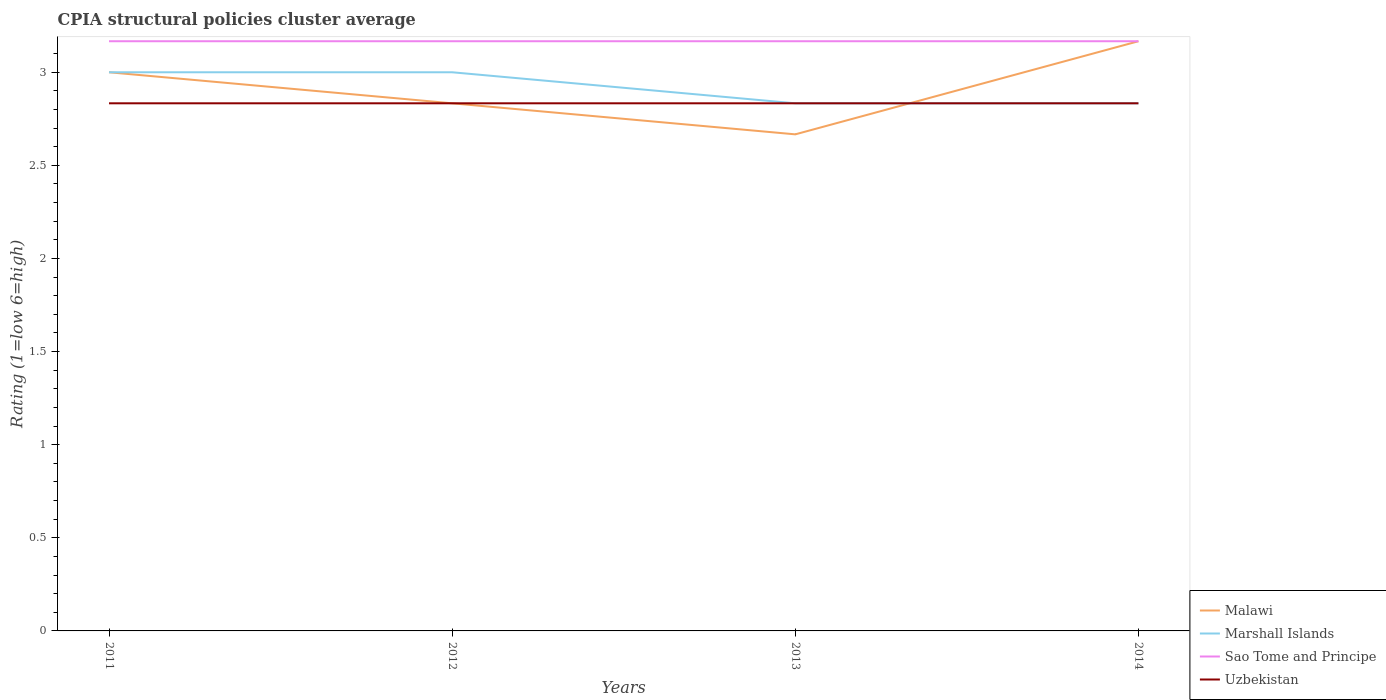Does the line corresponding to Malawi intersect with the line corresponding to Sao Tome and Principe?
Offer a very short reply. Yes. Across all years, what is the maximum CPIA rating in Marshall Islands?
Your response must be concise. 2.83. In which year was the CPIA rating in Marshall Islands maximum?
Ensure brevity in your answer.  2014. What is the total CPIA rating in Marshall Islands in the graph?
Keep it short and to the point. 0.17. What is the difference between the highest and the second highest CPIA rating in Marshall Islands?
Offer a very short reply. 0.17. How many years are there in the graph?
Make the answer very short. 4. Where does the legend appear in the graph?
Your answer should be very brief. Bottom right. How many legend labels are there?
Provide a succinct answer. 4. What is the title of the graph?
Provide a short and direct response. CPIA structural policies cluster average. Does "High income" appear as one of the legend labels in the graph?
Offer a very short reply. No. What is the Rating (1=low 6=high) of Malawi in 2011?
Provide a succinct answer. 3. What is the Rating (1=low 6=high) of Marshall Islands in 2011?
Provide a short and direct response. 3. What is the Rating (1=low 6=high) in Sao Tome and Principe in 2011?
Keep it short and to the point. 3.17. What is the Rating (1=low 6=high) of Uzbekistan in 2011?
Offer a very short reply. 2.83. What is the Rating (1=low 6=high) of Malawi in 2012?
Your answer should be compact. 2.83. What is the Rating (1=low 6=high) of Marshall Islands in 2012?
Offer a very short reply. 3. What is the Rating (1=low 6=high) in Sao Tome and Principe in 2012?
Your answer should be very brief. 3.17. What is the Rating (1=low 6=high) in Uzbekistan in 2012?
Offer a very short reply. 2.83. What is the Rating (1=low 6=high) of Malawi in 2013?
Your answer should be very brief. 2.67. What is the Rating (1=low 6=high) of Marshall Islands in 2013?
Your response must be concise. 2.83. What is the Rating (1=low 6=high) in Sao Tome and Principe in 2013?
Provide a short and direct response. 3.17. What is the Rating (1=low 6=high) in Uzbekistan in 2013?
Provide a succinct answer. 2.83. What is the Rating (1=low 6=high) of Malawi in 2014?
Offer a very short reply. 3.17. What is the Rating (1=low 6=high) of Marshall Islands in 2014?
Your response must be concise. 2.83. What is the Rating (1=low 6=high) of Sao Tome and Principe in 2014?
Provide a succinct answer. 3.17. What is the Rating (1=low 6=high) of Uzbekistan in 2014?
Your response must be concise. 2.83. Across all years, what is the maximum Rating (1=low 6=high) in Malawi?
Your response must be concise. 3.17. Across all years, what is the maximum Rating (1=low 6=high) of Sao Tome and Principe?
Provide a succinct answer. 3.17. Across all years, what is the maximum Rating (1=low 6=high) in Uzbekistan?
Keep it short and to the point. 2.83. Across all years, what is the minimum Rating (1=low 6=high) of Malawi?
Your answer should be compact. 2.67. Across all years, what is the minimum Rating (1=low 6=high) in Marshall Islands?
Offer a very short reply. 2.83. Across all years, what is the minimum Rating (1=low 6=high) of Sao Tome and Principe?
Your answer should be very brief. 3.17. Across all years, what is the minimum Rating (1=low 6=high) of Uzbekistan?
Give a very brief answer. 2.83. What is the total Rating (1=low 6=high) in Malawi in the graph?
Ensure brevity in your answer.  11.67. What is the total Rating (1=low 6=high) in Marshall Islands in the graph?
Make the answer very short. 11.67. What is the total Rating (1=low 6=high) of Sao Tome and Principe in the graph?
Provide a succinct answer. 12.67. What is the total Rating (1=low 6=high) of Uzbekistan in the graph?
Provide a short and direct response. 11.33. What is the difference between the Rating (1=low 6=high) of Malawi in 2011 and that in 2012?
Your answer should be compact. 0.17. What is the difference between the Rating (1=low 6=high) of Uzbekistan in 2011 and that in 2012?
Provide a succinct answer. 0. What is the difference between the Rating (1=low 6=high) in Malawi in 2011 and that in 2013?
Provide a succinct answer. 0.33. What is the difference between the Rating (1=low 6=high) in Marshall Islands in 2011 and that in 2013?
Offer a terse response. 0.17. What is the difference between the Rating (1=low 6=high) of Malawi in 2011 and that in 2014?
Your answer should be very brief. -0.17. What is the difference between the Rating (1=low 6=high) in Uzbekistan in 2012 and that in 2013?
Keep it short and to the point. 0. What is the difference between the Rating (1=low 6=high) of Malawi in 2012 and that in 2014?
Make the answer very short. -0.33. What is the difference between the Rating (1=low 6=high) in Marshall Islands in 2012 and that in 2014?
Make the answer very short. 0.17. What is the difference between the Rating (1=low 6=high) in Uzbekistan in 2012 and that in 2014?
Provide a succinct answer. 0. What is the difference between the Rating (1=low 6=high) in Marshall Islands in 2013 and that in 2014?
Ensure brevity in your answer.  0. What is the difference between the Rating (1=low 6=high) in Sao Tome and Principe in 2013 and that in 2014?
Ensure brevity in your answer.  -0. What is the difference between the Rating (1=low 6=high) in Uzbekistan in 2013 and that in 2014?
Keep it short and to the point. 0. What is the difference between the Rating (1=low 6=high) of Malawi in 2011 and the Rating (1=low 6=high) of Uzbekistan in 2012?
Ensure brevity in your answer.  0.17. What is the difference between the Rating (1=low 6=high) in Marshall Islands in 2011 and the Rating (1=low 6=high) in Sao Tome and Principe in 2012?
Keep it short and to the point. -0.17. What is the difference between the Rating (1=low 6=high) of Marshall Islands in 2011 and the Rating (1=low 6=high) of Uzbekistan in 2012?
Provide a succinct answer. 0.17. What is the difference between the Rating (1=low 6=high) in Malawi in 2011 and the Rating (1=low 6=high) in Sao Tome and Principe in 2013?
Offer a terse response. -0.17. What is the difference between the Rating (1=low 6=high) in Malawi in 2011 and the Rating (1=low 6=high) in Uzbekistan in 2013?
Give a very brief answer. 0.17. What is the difference between the Rating (1=low 6=high) in Marshall Islands in 2011 and the Rating (1=low 6=high) in Uzbekistan in 2013?
Give a very brief answer. 0.17. What is the difference between the Rating (1=low 6=high) of Malawi in 2011 and the Rating (1=low 6=high) of Marshall Islands in 2014?
Your answer should be very brief. 0.17. What is the difference between the Rating (1=low 6=high) in Malawi in 2011 and the Rating (1=low 6=high) in Sao Tome and Principe in 2014?
Your response must be concise. -0.17. What is the difference between the Rating (1=low 6=high) of Marshall Islands in 2011 and the Rating (1=low 6=high) of Sao Tome and Principe in 2014?
Your response must be concise. -0.17. What is the difference between the Rating (1=low 6=high) in Sao Tome and Principe in 2011 and the Rating (1=low 6=high) in Uzbekistan in 2014?
Provide a short and direct response. 0.33. What is the difference between the Rating (1=low 6=high) in Malawi in 2012 and the Rating (1=low 6=high) in Sao Tome and Principe in 2013?
Your answer should be very brief. -0.33. What is the difference between the Rating (1=low 6=high) in Malawi in 2012 and the Rating (1=low 6=high) in Uzbekistan in 2013?
Offer a very short reply. 0. What is the difference between the Rating (1=low 6=high) in Marshall Islands in 2012 and the Rating (1=low 6=high) in Sao Tome and Principe in 2013?
Provide a short and direct response. -0.17. What is the difference between the Rating (1=low 6=high) in Marshall Islands in 2012 and the Rating (1=low 6=high) in Sao Tome and Principe in 2014?
Your answer should be compact. -0.17. What is the difference between the Rating (1=low 6=high) of Marshall Islands in 2012 and the Rating (1=low 6=high) of Uzbekistan in 2014?
Make the answer very short. 0.17. What is the difference between the Rating (1=low 6=high) of Malawi in 2013 and the Rating (1=low 6=high) of Uzbekistan in 2014?
Your response must be concise. -0.17. What is the difference between the Rating (1=low 6=high) of Sao Tome and Principe in 2013 and the Rating (1=low 6=high) of Uzbekistan in 2014?
Ensure brevity in your answer.  0.33. What is the average Rating (1=low 6=high) in Malawi per year?
Keep it short and to the point. 2.92. What is the average Rating (1=low 6=high) of Marshall Islands per year?
Ensure brevity in your answer.  2.92. What is the average Rating (1=low 6=high) of Sao Tome and Principe per year?
Offer a very short reply. 3.17. What is the average Rating (1=low 6=high) of Uzbekistan per year?
Offer a very short reply. 2.83. In the year 2011, what is the difference between the Rating (1=low 6=high) in Malawi and Rating (1=low 6=high) in Sao Tome and Principe?
Your answer should be very brief. -0.17. In the year 2011, what is the difference between the Rating (1=low 6=high) in Malawi and Rating (1=low 6=high) in Uzbekistan?
Keep it short and to the point. 0.17. In the year 2012, what is the difference between the Rating (1=low 6=high) in Malawi and Rating (1=low 6=high) in Marshall Islands?
Your answer should be very brief. -0.17. In the year 2012, what is the difference between the Rating (1=low 6=high) of Malawi and Rating (1=low 6=high) of Sao Tome and Principe?
Your answer should be very brief. -0.33. In the year 2012, what is the difference between the Rating (1=low 6=high) of Malawi and Rating (1=low 6=high) of Uzbekistan?
Give a very brief answer. 0. In the year 2012, what is the difference between the Rating (1=low 6=high) of Marshall Islands and Rating (1=low 6=high) of Uzbekistan?
Provide a succinct answer. 0.17. In the year 2012, what is the difference between the Rating (1=low 6=high) of Sao Tome and Principe and Rating (1=low 6=high) of Uzbekistan?
Provide a succinct answer. 0.33. In the year 2013, what is the difference between the Rating (1=low 6=high) of Malawi and Rating (1=low 6=high) of Marshall Islands?
Offer a terse response. -0.17. In the year 2013, what is the difference between the Rating (1=low 6=high) of Malawi and Rating (1=low 6=high) of Sao Tome and Principe?
Provide a succinct answer. -0.5. In the year 2013, what is the difference between the Rating (1=low 6=high) in Malawi and Rating (1=low 6=high) in Uzbekistan?
Keep it short and to the point. -0.17. In the year 2013, what is the difference between the Rating (1=low 6=high) of Marshall Islands and Rating (1=low 6=high) of Uzbekistan?
Provide a succinct answer. 0. In the year 2014, what is the difference between the Rating (1=low 6=high) in Malawi and Rating (1=low 6=high) in Marshall Islands?
Make the answer very short. 0.33. In the year 2014, what is the difference between the Rating (1=low 6=high) of Marshall Islands and Rating (1=low 6=high) of Sao Tome and Principe?
Provide a succinct answer. -0.33. In the year 2014, what is the difference between the Rating (1=low 6=high) in Sao Tome and Principe and Rating (1=low 6=high) in Uzbekistan?
Offer a very short reply. 0.33. What is the ratio of the Rating (1=low 6=high) of Malawi in 2011 to that in 2012?
Provide a succinct answer. 1.06. What is the ratio of the Rating (1=low 6=high) in Marshall Islands in 2011 to that in 2012?
Provide a succinct answer. 1. What is the ratio of the Rating (1=low 6=high) in Uzbekistan in 2011 to that in 2012?
Your answer should be compact. 1. What is the ratio of the Rating (1=low 6=high) in Marshall Islands in 2011 to that in 2013?
Your answer should be compact. 1.06. What is the ratio of the Rating (1=low 6=high) of Marshall Islands in 2011 to that in 2014?
Ensure brevity in your answer.  1.06. What is the ratio of the Rating (1=low 6=high) in Sao Tome and Principe in 2011 to that in 2014?
Ensure brevity in your answer.  1. What is the ratio of the Rating (1=low 6=high) of Uzbekistan in 2011 to that in 2014?
Ensure brevity in your answer.  1. What is the ratio of the Rating (1=low 6=high) in Marshall Islands in 2012 to that in 2013?
Your answer should be compact. 1.06. What is the ratio of the Rating (1=low 6=high) in Sao Tome and Principe in 2012 to that in 2013?
Your response must be concise. 1. What is the ratio of the Rating (1=low 6=high) of Uzbekistan in 2012 to that in 2013?
Offer a terse response. 1. What is the ratio of the Rating (1=low 6=high) of Malawi in 2012 to that in 2014?
Offer a very short reply. 0.89. What is the ratio of the Rating (1=low 6=high) in Marshall Islands in 2012 to that in 2014?
Offer a terse response. 1.06. What is the ratio of the Rating (1=low 6=high) in Sao Tome and Principe in 2012 to that in 2014?
Make the answer very short. 1. What is the ratio of the Rating (1=low 6=high) in Uzbekistan in 2012 to that in 2014?
Offer a terse response. 1. What is the ratio of the Rating (1=low 6=high) in Malawi in 2013 to that in 2014?
Make the answer very short. 0.84. What is the ratio of the Rating (1=low 6=high) of Marshall Islands in 2013 to that in 2014?
Keep it short and to the point. 1. What is the difference between the highest and the second highest Rating (1=low 6=high) in Malawi?
Ensure brevity in your answer.  0.17. What is the difference between the highest and the second highest Rating (1=low 6=high) of Marshall Islands?
Your answer should be compact. 0. What is the difference between the highest and the second highest Rating (1=low 6=high) in Sao Tome and Principe?
Provide a succinct answer. 0. What is the difference between the highest and the second highest Rating (1=low 6=high) in Uzbekistan?
Provide a succinct answer. 0. What is the difference between the highest and the lowest Rating (1=low 6=high) in Malawi?
Your answer should be very brief. 0.5. What is the difference between the highest and the lowest Rating (1=low 6=high) of Sao Tome and Principe?
Make the answer very short. 0. 